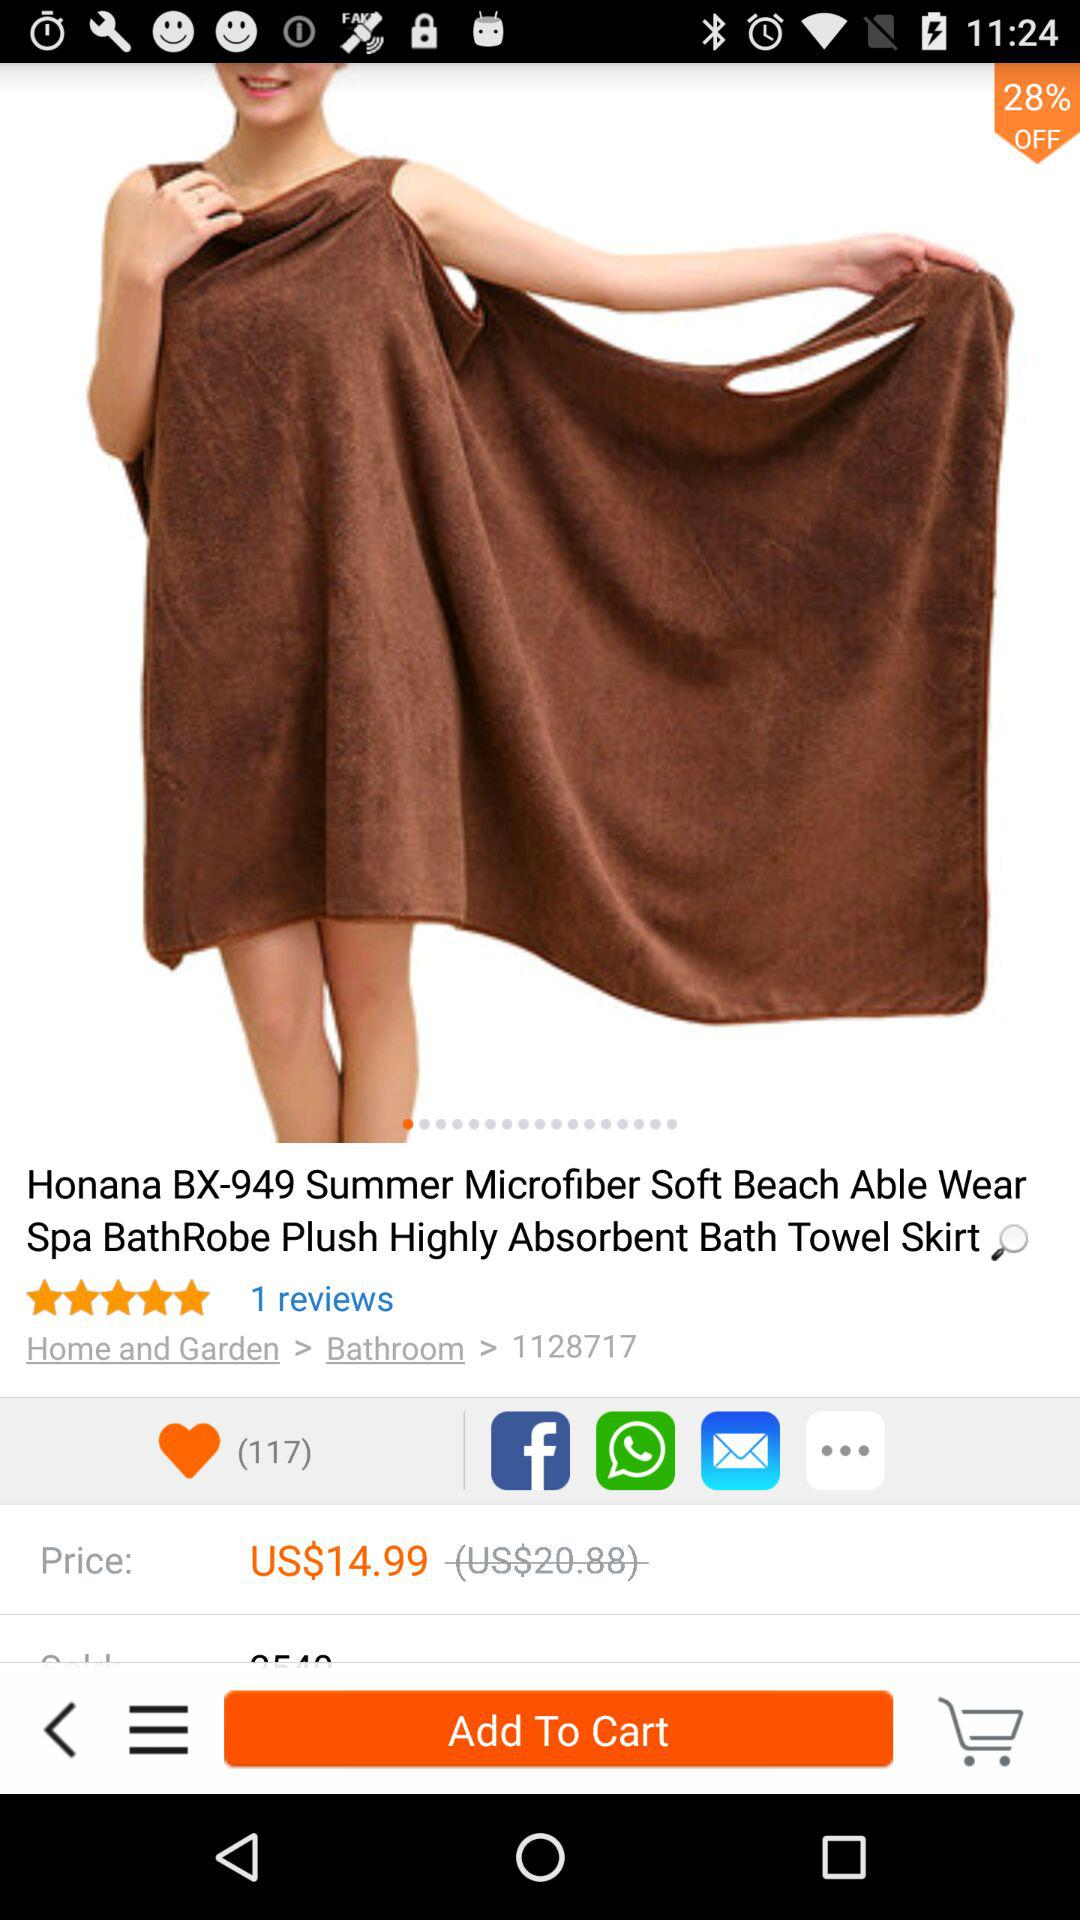What's the off percentage on the product? The off percentage on the product is 28. 